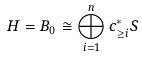Convert formula to latex. <formula><loc_0><loc_0><loc_500><loc_500>H = B _ { 0 } \cong \bigoplus _ { i = 1 } ^ { n } c _ { \geq i } ^ { \ast } S</formula> 